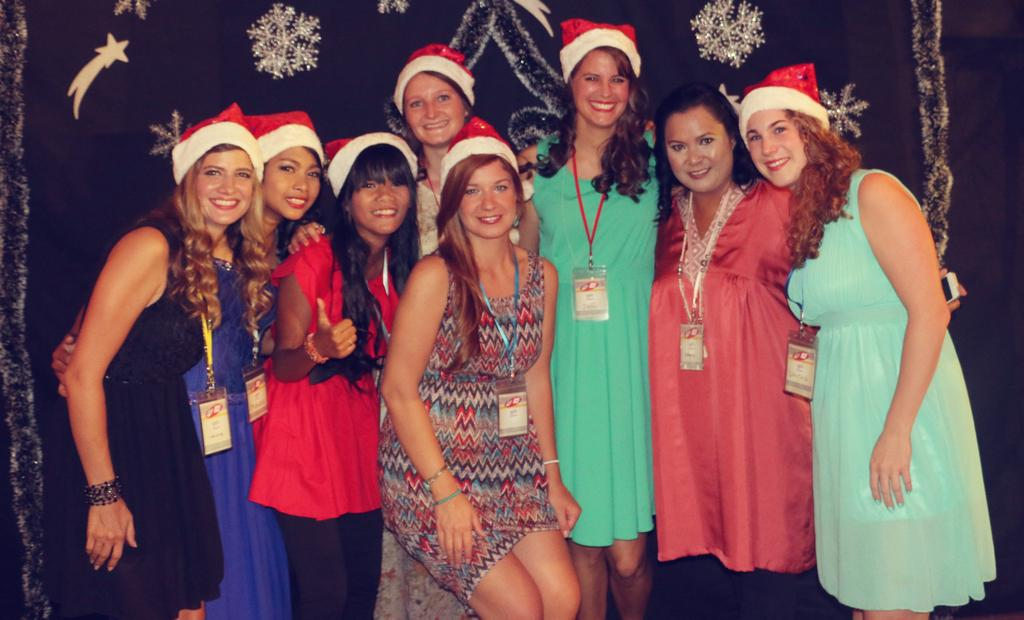What is happening in the middle of the image? There are women standing in the middle of the image. How are the women in the image feeling? The women are smiling in the image. What can be seen behind the women? There is a curtain visible behind the women. What type of blood is dripping from the queen's crown in the image? There is no queen or blood present in the image; it features women standing and smiling with a curtain in the background. 